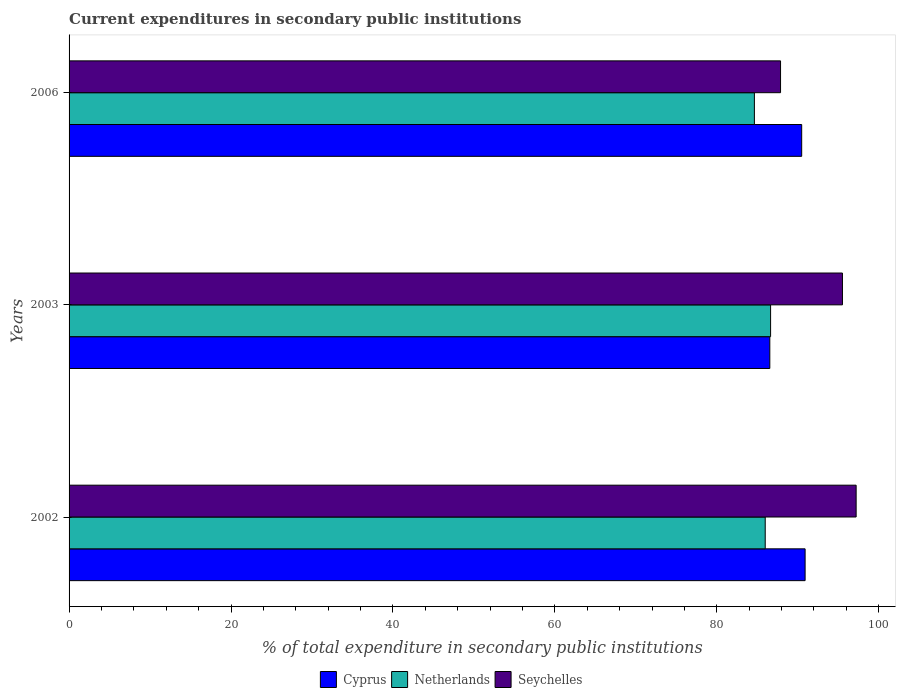How many different coloured bars are there?
Provide a succinct answer. 3. How many groups of bars are there?
Ensure brevity in your answer.  3. Are the number of bars per tick equal to the number of legend labels?
Keep it short and to the point. Yes. Are the number of bars on each tick of the Y-axis equal?
Your response must be concise. Yes. How many bars are there on the 2nd tick from the bottom?
Keep it short and to the point. 3. What is the current expenditures in secondary public institutions in Cyprus in 2002?
Offer a very short reply. 90.91. Across all years, what is the maximum current expenditures in secondary public institutions in Netherlands?
Your answer should be compact. 86.65. Across all years, what is the minimum current expenditures in secondary public institutions in Cyprus?
Give a very brief answer. 86.55. In which year was the current expenditures in secondary public institutions in Cyprus maximum?
Make the answer very short. 2002. What is the total current expenditures in secondary public institutions in Netherlands in the graph?
Provide a short and direct response. 257.27. What is the difference between the current expenditures in secondary public institutions in Netherlands in 2002 and that in 2003?
Ensure brevity in your answer.  -0.66. What is the difference between the current expenditures in secondary public institutions in Seychelles in 2003 and the current expenditures in secondary public institutions in Netherlands in 2002?
Keep it short and to the point. 9.54. What is the average current expenditures in secondary public institutions in Netherlands per year?
Make the answer very short. 85.76. In the year 2002, what is the difference between the current expenditures in secondary public institutions in Cyprus and current expenditures in secondary public institutions in Seychelles?
Make the answer very short. -6.3. In how many years, is the current expenditures in secondary public institutions in Netherlands greater than 48 %?
Offer a very short reply. 3. What is the ratio of the current expenditures in secondary public institutions in Seychelles in 2002 to that in 2006?
Your answer should be very brief. 1.11. Is the difference between the current expenditures in secondary public institutions in Cyprus in 2002 and 2003 greater than the difference between the current expenditures in secondary public institutions in Seychelles in 2002 and 2003?
Provide a succinct answer. Yes. What is the difference between the highest and the second highest current expenditures in secondary public institutions in Netherlands?
Make the answer very short. 0.66. What is the difference between the highest and the lowest current expenditures in secondary public institutions in Netherlands?
Your answer should be very brief. 2. Is the sum of the current expenditures in secondary public institutions in Cyprus in 2002 and 2003 greater than the maximum current expenditures in secondary public institutions in Seychelles across all years?
Make the answer very short. Yes. Is it the case that in every year, the sum of the current expenditures in secondary public institutions in Seychelles and current expenditures in secondary public institutions in Netherlands is greater than the current expenditures in secondary public institutions in Cyprus?
Provide a succinct answer. Yes. What is the difference between two consecutive major ticks on the X-axis?
Ensure brevity in your answer.  20. Does the graph contain any zero values?
Offer a very short reply. No. Does the graph contain grids?
Give a very brief answer. No. How many legend labels are there?
Keep it short and to the point. 3. What is the title of the graph?
Ensure brevity in your answer.  Current expenditures in secondary public institutions. Does "Liberia" appear as one of the legend labels in the graph?
Provide a succinct answer. No. What is the label or title of the X-axis?
Your answer should be very brief. % of total expenditure in secondary public institutions. What is the label or title of the Y-axis?
Make the answer very short. Years. What is the % of total expenditure in secondary public institutions of Cyprus in 2002?
Your answer should be compact. 90.91. What is the % of total expenditure in secondary public institutions in Netherlands in 2002?
Offer a terse response. 85.98. What is the % of total expenditure in secondary public institutions of Seychelles in 2002?
Give a very brief answer. 97.21. What is the % of total expenditure in secondary public institutions of Cyprus in 2003?
Give a very brief answer. 86.55. What is the % of total expenditure in secondary public institutions in Netherlands in 2003?
Your answer should be very brief. 86.65. What is the % of total expenditure in secondary public institutions of Seychelles in 2003?
Give a very brief answer. 95.52. What is the % of total expenditure in secondary public institutions of Cyprus in 2006?
Keep it short and to the point. 90.49. What is the % of total expenditure in secondary public institutions of Netherlands in 2006?
Offer a terse response. 84.65. What is the % of total expenditure in secondary public institutions in Seychelles in 2006?
Your answer should be very brief. 87.88. Across all years, what is the maximum % of total expenditure in secondary public institutions in Cyprus?
Offer a very short reply. 90.91. Across all years, what is the maximum % of total expenditure in secondary public institutions in Netherlands?
Keep it short and to the point. 86.65. Across all years, what is the maximum % of total expenditure in secondary public institutions of Seychelles?
Your response must be concise. 97.21. Across all years, what is the minimum % of total expenditure in secondary public institutions of Cyprus?
Give a very brief answer. 86.55. Across all years, what is the minimum % of total expenditure in secondary public institutions of Netherlands?
Provide a short and direct response. 84.65. Across all years, what is the minimum % of total expenditure in secondary public institutions of Seychelles?
Offer a very short reply. 87.88. What is the total % of total expenditure in secondary public institutions in Cyprus in the graph?
Keep it short and to the point. 267.95. What is the total % of total expenditure in secondary public institutions of Netherlands in the graph?
Your response must be concise. 257.27. What is the total % of total expenditure in secondary public institutions in Seychelles in the graph?
Provide a short and direct response. 280.61. What is the difference between the % of total expenditure in secondary public institutions in Cyprus in 2002 and that in 2003?
Ensure brevity in your answer.  4.36. What is the difference between the % of total expenditure in secondary public institutions of Netherlands in 2002 and that in 2003?
Offer a very short reply. -0.66. What is the difference between the % of total expenditure in secondary public institutions in Seychelles in 2002 and that in 2003?
Ensure brevity in your answer.  1.69. What is the difference between the % of total expenditure in secondary public institutions of Cyprus in 2002 and that in 2006?
Keep it short and to the point. 0.42. What is the difference between the % of total expenditure in secondary public institutions of Netherlands in 2002 and that in 2006?
Your answer should be very brief. 1.34. What is the difference between the % of total expenditure in secondary public institutions of Seychelles in 2002 and that in 2006?
Your answer should be very brief. 9.34. What is the difference between the % of total expenditure in secondary public institutions of Cyprus in 2003 and that in 2006?
Make the answer very short. -3.94. What is the difference between the % of total expenditure in secondary public institutions in Netherlands in 2003 and that in 2006?
Keep it short and to the point. 2. What is the difference between the % of total expenditure in secondary public institutions of Seychelles in 2003 and that in 2006?
Offer a very short reply. 7.65. What is the difference between the % of total expenditure in secondary public institutions of Cyprus in 2002 and the % of total expenditure in secondary public institutions of Netherlands in 2003?
Offer a very short reply. 4.26. What is the difference between the % of total expenditure in secondary public institutions of Cyprus in 2002 and the % of total expenditure in secondary public institutions of Seychelles in 2003?
Your answer should be compact. -4.61. What is the difference between the % of total expenditure in secondary public institutions in Netherlands in 2002 and the % of total expenditure in secondary public institutions in Seychelles in 2003?
Keep it short and to the point. -9.54. What is the difference between the % of total expenditure in secondary public institutions in Cyprus in 2002 and the % of total expenditure in secondary public institutions in Netherlands in 2006?
Your answer should be compact. 6.26. What is the difference between the % of total expenditure in secondary public institutions in Cyprus in 2002 and the % of total expenditure in secondary public institutions in Seychelles in 2006?
Your answer should be compact. 3.03. What is the difference between the % of total expenditure in secondary public institutions in Netherlands in 2002 and the % of total expenditure in secondary public institutions in Seychelles in 2006?
Your answer should be very brief. -1.89. What is the difference between the % of total expenditure in secondary public institutions in Cyprus in 2003 and the % of total expenditure in secondary public institutions in Netherlands in 2006?
Offer a very short reply. 1.9. What is the difference between the % of total expenditure in secondary public institutions in Cyprus in 2003 and the % of total expenditure in secondary public institutions in Seychelles in 2006?
Your answer should be very brief. -1.33. What is the difference between the % of total expenditure in secondary public institutions of Netherlands in 2003 and the % of total expenditure in secondary public institutions of Seychelles in 2006?
Offer a very short reply. -1.23. What is the average % of total expenditure in secondary public institutions of Cyprus per year?
Your answer should be compact. 89.32. What is the average % of total expenditure in secondary public institutions in Netherlands per year?
Provide a short and direct response. 85.76. What is the average % of total expenditure in secondary public institutions of Seychelles per year?
Your answer should be very brief. 93.54. In the year 2002, what is the difference between the % of total expenditure in secondary public institutions in Cyprus and % of total expenditure in secondary public institutions in Netherlands?
Offer a very short reply. 4.93. In the year 2002, what is the difference between the % of total expenditure in secondary public institutions of Cyprus and % of total expenditure in secondary public institutions of Seychelles?
Your answer should be compact. -6.3. In the year 2002, what is the difference between the % of total expenditure in secondary public institutions of Netherlands and % of total expenditure in secondary public institutions of Seychelles?
Keep it short and to the point. -11.23. In the year 2003, what is the difference between the % of total expenditure in secondary public institutions in Cyprus and % of total expenditure in secondary public institutions in Netherlands?
Give a very brief answer. -0.1. In the year 2003, what is the difference between the % of total expenditure in secondary public institutions in Cyprus and % of total expenditure in secondary public institutions in Seychelles?
Offer a very short reply. -8.97. In the year 2003, what is the difference between the % of total expenditure in secondary public institutions in Netherlands and % of total expenditure in secondary public institutions in Seychelles?
Ensure brevity in your answer.  -8.88. In the year 2006, what is the difference between the % of total expenditure in secondary public institutions in Cyprus and % of total expenditure in secondary public institutions in Netherlands?
Give a very brief answer. 5.84. In the year 2006, what is the difference between the % of total expenditure in secondary public institutions of Cyprus and % of total expenditure in secondary public institutions of Seychelles?
Give a very brief answer. 2.61. In the year 2006, what is the difference between the % of total expenditure in secondary public institutions in Netherlands and % of total expenditure in secondary public institutions in Seychelles?
Make the answer very short. -3.23. What is the ratio of the % of total expenditure in secondary public institutions in Cyprus in 2002 to that in 2003?
Keep it short and to the point. 1.05. What is the ratio of the % of total expenditure in secondary public institutions of Seychelles in 2002 to that in 2003?
Provide a short and direct response. 1.02. What is the ratio of the % of total expenditure in secondary public institutions of Cyprus in 2002 to that in 2006?
Provide a short and direct response. 1. What is the ratio of the % of total expenditure in secondary public institutions in Netherlands in 2002 to that in 2006?
Your response must be concise. 1.02. What is the ratio of the % of total expenditure in secondary public institutions of Seychelles in 2002 to that in 2006?
Provide a short and direct response. 1.11. What is the ratio of the % of total expenditure in secondary public institutions in Cyprus in 2003 to that in 2006?
Offer a terse response. 0.96. What is the ratio of the % of total expenditure in secondary public institutions in Netherlands in 2003 to that in 2006?
Your response must be concise. 1.02. What is the ratio of the % of total expenditure in secondary public institutions in Seychelles in 2003 to that in 2006?
Offer a terse response. 1.09. What is the difference between the highest and the second highest % of total expenditure in secondary public institutions in Cyprus?
Offer a very short reply. 0.42. What is the difference between the highest and the second highest % of total expenditure in secondary public institutions of Netherlands?
Your answer should be very brief. 0.66. What is the difference between the highest and the second highest % of total expenditure in secondary public institutions in Seychelles?
Your response must be concise. 1.69. What is the difference between the highest and the lowest % of total expenditure in secondary public institutions of Cyprus?
Give a very brief answer. 4.36. What is the difference between the highest and the lowest % of total expenditure in secondary public institutions in Netherlands?
Give a very brief answer. 2. What is the difference between the highest and the lowest % of total expenditure in secondary public institutions in Seychelles?
Keep it short and to the point. 9.34. 